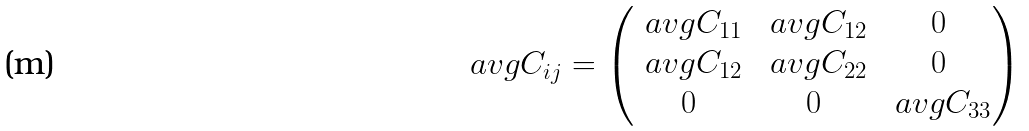<formula> <loc_0><loc_0><loc_500><loc_500>\ a v g { C _ { i j } } = \begin{pmatrix} \ a v g { C _ { 1 1 } } & \ a v g { C _ { 1 2 } } & 0 \\ \ a v g { C _ { 1 2 } } & \ a v g { C _ { 2 2 } } & 0 \\ 0 & 0 & \ a v g { C _ { 3 3 } } \end{pmatrix}</formula> 